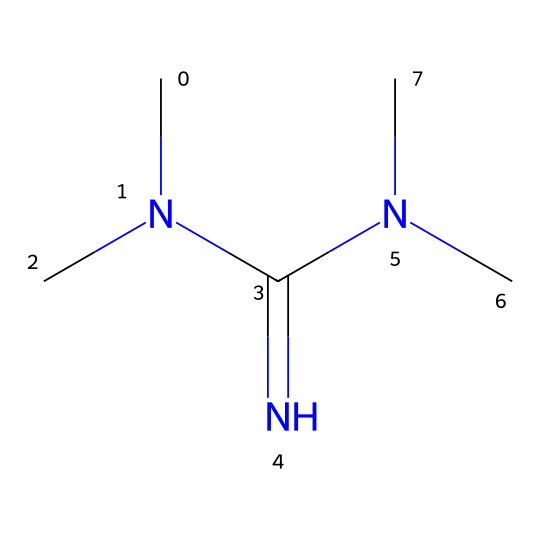What is the molecular formula of tetramethylguanidine? By analyzing the provided SMILES representation, we can count the atoms: there are 6 carbon atoms (C), 15 hydrogen atoms (H), and 4 nitrogen atoms (N). This gives the molecular formula as C6H15N5.
Answer: C6H15N5 How many nitrogen atoms are present in tetramethylguanidine? Counting the 'N' symbols in the SMILES representation shows there are four nitrogen atoms.
Answer: 4 What type of chemical is tetramethylguanidine categorized as? Tetramethylguanidine is a superbase due to its ability to deprotonate weak acids, indicated by the high number of nitrogen atoms contributing to its basicity.
Answer: superbase Is tetramethylguanidine considered hygroscopic? Yes, tetramethylguanidine is hygroscopic, meaning it can absorb moisture from the air, which aligns with many compounds in its category.
Answer: yes What functional group is dominant in tetramethylguanidine? The structure features a guanidine core, which has the guanidino functional group characterized by three nitrogen atoms connected to a carbon atom.
Answer: guanidino What is the primary use of tetramethylguanidine in diagnostic reagents? Tetramethylguanidine is used primarily as a catalyst in various chemical reactions due to its strong basicity, facilitating certain diagnostic tests by speeding up reactions.
Answer: catalyst 